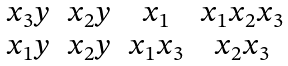<formula> <loc_0><loc_0><loc_500><loc_500>\begin{matrix} x _ { 3 } y & x _ { 2 } y & x _ { 1 } & x _ { 1 } x _ { 2 } x _ { 3 } \\ x _ { 1 } y & x _ { 2 } y & x _ { 1 } x _ { 3 } & x _ { 2 } x _ { 3 } \end{matrix}</formula> 